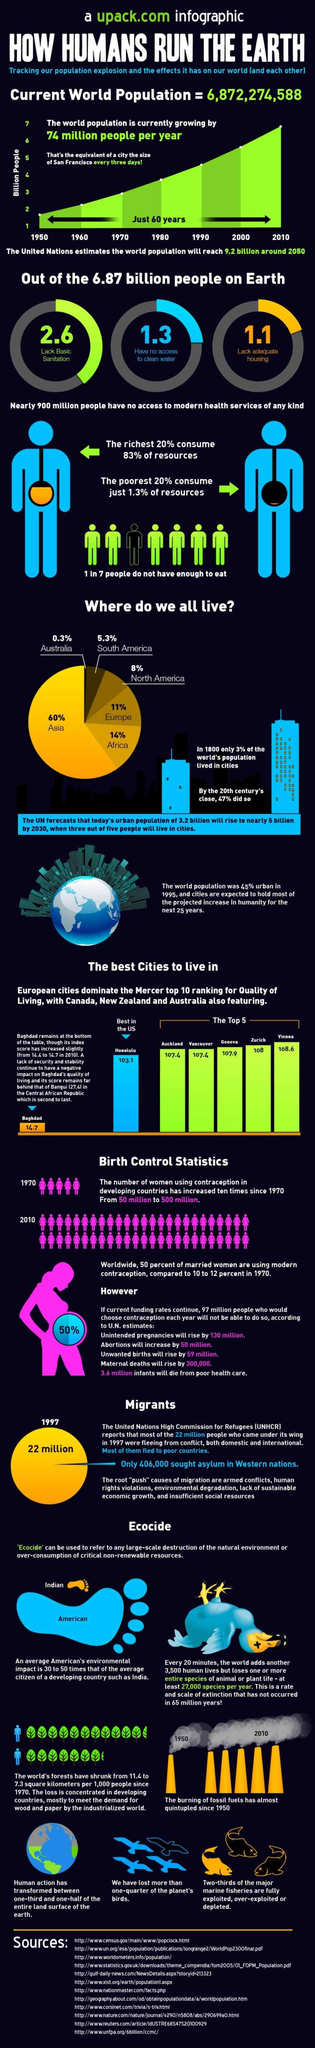List a handful of essential elements in this visual. According to estimates, approximately 1.3 billion people worldwide lack access to clean water, a critical issue that affects their health, livelihoods, and overall well-being. Asia is the most densely populated continent in the world. According to recent estimates, approximately 2.6 billion people around the world lack basic sanitation facilities, posing significant health risks and hindering economic development in many areas. Approximately 11% of the world's population resides in Europe. Honolulu, a city in the United States, has been ranked as the top city for the quality of living in the country. 